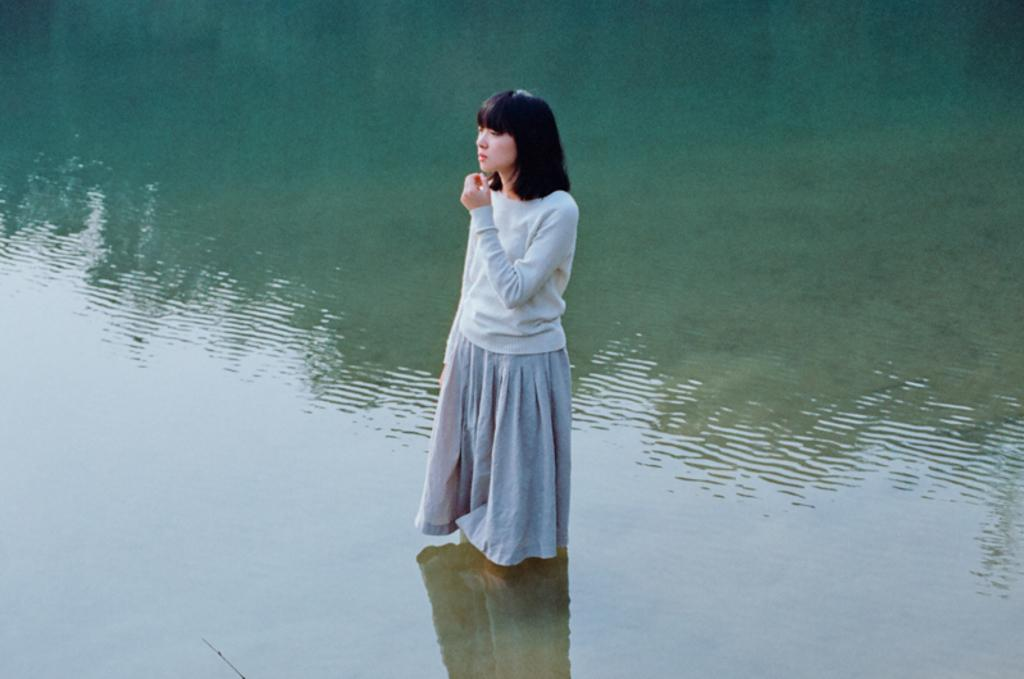What is the main subject of the image? There is a person in the image. Can you describe the person's location in the image? The person is standing in the water. What type of quiver is the person holding in the image? There is no quiver present in the image; the person is standing in the water. How many frames are visible in the image? There are no frames present in the image; it is a photograph of a person standing in the water. 